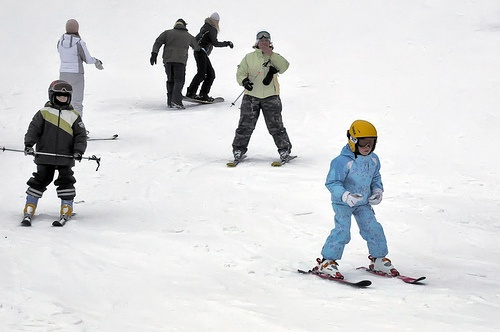Describe the objects in this image and their specific colors. I can see people in lightgray, gray, lightblue, and darkgray tones, people in lightgray, black, gray, darkgray, and olive tones, people in lightgray, black, darkgray, gray, and white tones, people in lightgray, black, white, gray, and darkgray tones, and people in lightgray, black, gray, white, and darkgray tones in this image. 